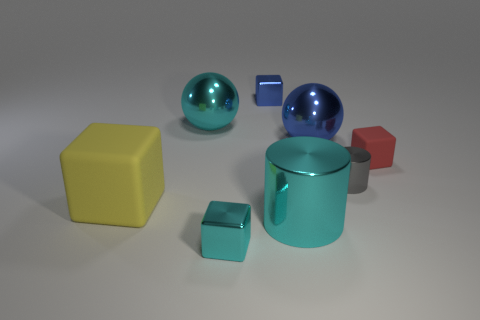Add 1 red spheres. How many objects exist? 9 Subtract all balls. How many objects are left? 6 Subtract all blue metallic spheres. Subtract all brown shiny things. How many objects are left? 7 Add 8 rubber cubes. How many rubber cubes are left? 10 Add 4 large cyan shiny cylinders. How many large cyan shiny cylinders exist? 5 Subtract 0 yellow balls. How many objects are left? 8 